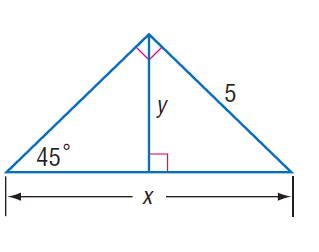Question: Find x.
Choices:
A. 5
B. 5 \sqrt { 2 }
C. 10
D. 10 \sqrt { 2 }
Answer with the letter. Answer: B 